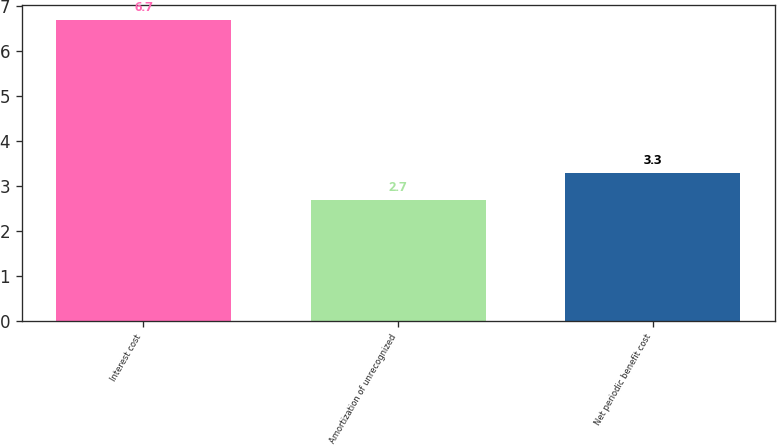Convert chart to OTSL. <chart><loc_0><loc_0><loc_500><loc_500><bar_chart><fcel>Interest cost<fcel>Amortization of unrecognized<fcel>Net periodic benefit cost<nl><fcel>6.7<fcel>2.7<fcel>3.3<nl></chart> 